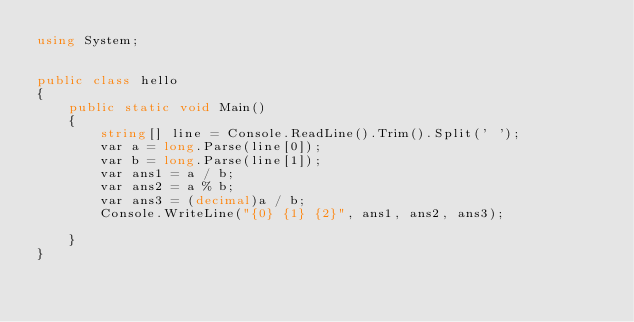<code> <loc_0><loc_0><loc_500><loc_500><_C#_>using System;


public class hello
{
    public static void Main()
    {
        string[] line = Console.ReadLine().Trim().Split(' ');
        var a = long.Parse(line[0]);
        var b = long.Parse(line[1]);
        var ans1 = a / b;
        var ans2 = a % b;
        var ans3 = (decimal)a / b;
        Console.WriteLine("{0} {1} {2}", ans1, ans2, ans3);

    }
}</code> 